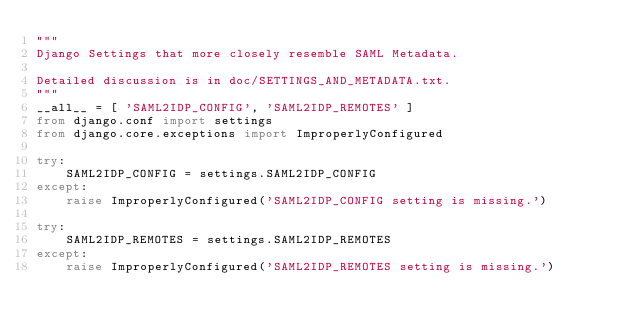<code> <loc_0><loc_0><loc_500><loc_500><_Python_>"""
Django Settings that more closely resemble SAML Metadata.

Detailed discussion is in doc/SETTINGS_AND_METADATA.txt.
"""
__all__ = [ 'SAML2IDP_CONFIG', 'SAML2IDP_REMOTES' ]
from django.conf import settings
from django.core.exceptions import ImproperlyConfigured

try:
    SAML2IDP_CONFIG = settings.SAML2IDP_CONFIG
except:
    raise ImproperlyConfigured('SAML2IDP_CONFIG setting is missing.')

try:
    SAML2IDP_REMOTES = settings.SAML2IDP_REMOTES
except:
    raise ImproperlyConfigured('SAML2IDP_REMOTES setting is missing.')
</code> 